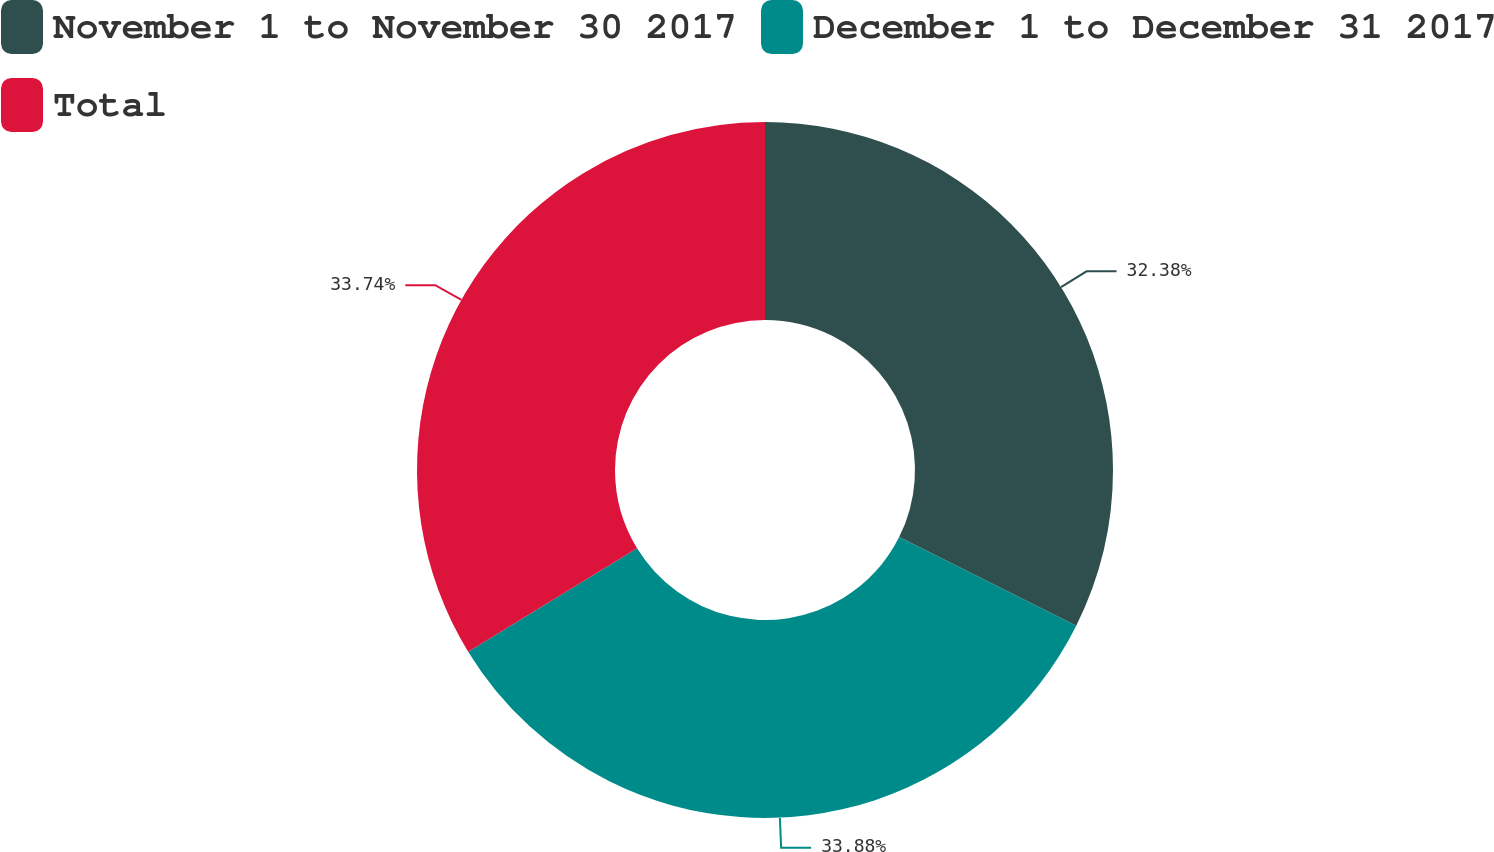Convert chart to OTSL. <chart><loc_0><loc_0><loc_500><loc_500><pie_chart><fcel>November 1 to November 30 2017<fcel>December 1 to December 31 2017<fcel>Total<nl><fcel>32.38%<fcel>33.88%<fcel>33.74%<nl></chart> 